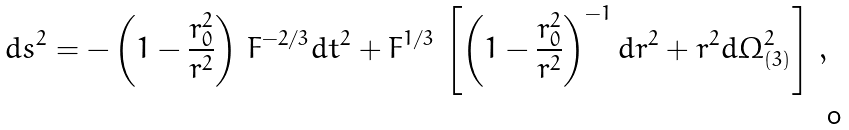Convert formula to latex. <formula><loc_0><loc_0><loc_500><loc_500>d s ^ { 2 } = - \left ( 1 - \frac { r _ { 0 } ^ { 2 } } { r ^ { 2 } } \right ) \, F ^ { - 2 / 3 } d t ^ { 2 } + F ^ { 1 / 3 } \, \left [ \left ( 1 - \frac { r _ { 0 } ^ { 2 } } { r ^ { 2 } } \right ) ^ { - 1 } d r ^ { 2 } + r ^ { 2 } d \Omega _ { ( 3 ) } ^ { 2 } \right ] \, ,</formula> 